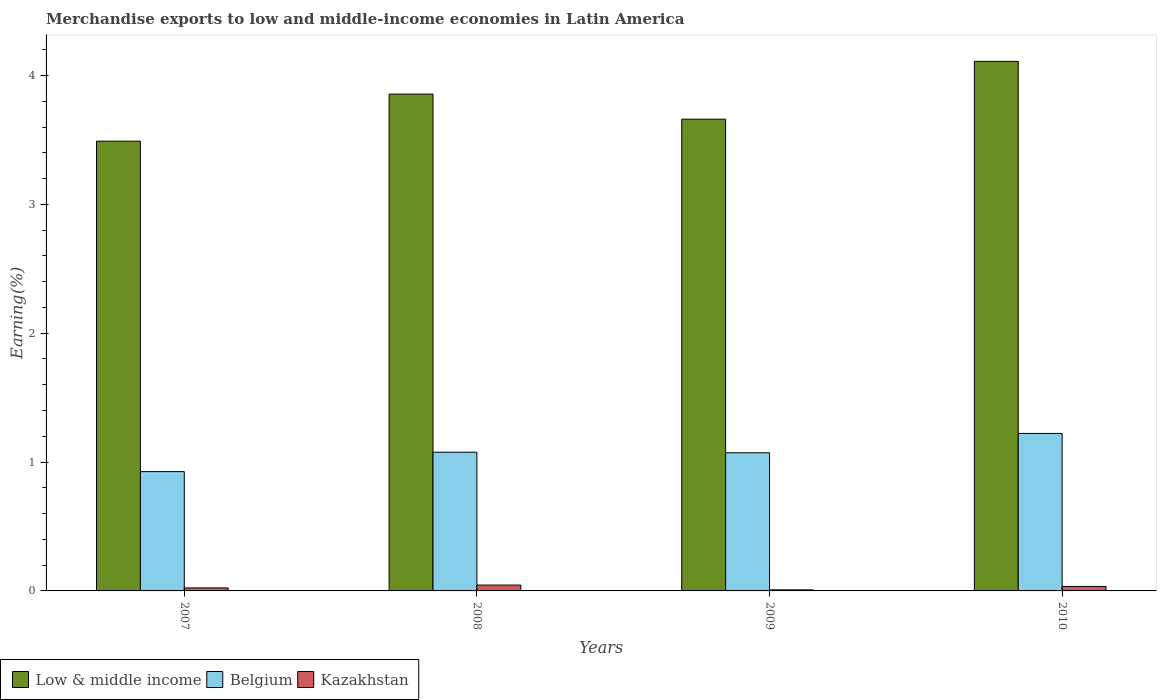How many different coloured bars are there?
Your answer should be compact. 3. Are the number of bars on each tick of the X-axis equal?
Your answer should be very brief. Yes. In how many cases, is the number of bars for a given year not equal to the number of legend labels?
Provide a succinct answer. 0. What is the percentage of amount earned from merchandise exports in Belgium in 2010?
Your response must be concise. 1.22. Across all years, what is the maximum percentage of amount earned from merchandise exports in Kazakhstan?
Ensure brevity in your answer.  0.05. Across all years, what is the minimum percentage of amount earned from merchandise exports in Belgium?
Your answer should be compact. 0.93. In which year was the percentage of amount earned from merchandise exports in Low & middle income maximum?
Your answer should be compact. 2010. In which year was the percentage of amount earned from merchandise exports in Belgium minimum?
Keep it short and to the point. 2007. What is the total percentage of amount earned from merchandise exports in Low & middle income in the graph?
Offer a very short reply. 15.12. What is the difference between the percentage of amount earned from merchandise exports in Low & middle income in 2008 and that in 2009?
Make the answer very short. 0.19. What is the difference between the percentage of amount earned from merchandise exports in Low & middle income in 2008 and the percentage of amount earned from merchandise exports in Kazakhstan in 2009?
Give a very brief answer. 3.85. What is the average percentage of amount earned from merchandise exports in Kazakhstan per year?
Your answer should be compact. 0.03. In the year 2009, what is the difference between the percentage of amount earned from merchandise exports in Kazakhstan and percentage of amount earned from merchandise exports in Belgium?
Give a very brief answer. -1.06. What is the ratio of the percentage of amount earned from merchandise exports in Belgium in 2009 to that in 2010?
Make the answer very short. 0.88. Is the difference between the percentage of amount earned from merchandise exports in Kazakhstan in 2007 and 2010 greater than the difference between the percentage of amount earned from merchandise exports in Belgium in 2007 and 2010?
Give a very brief answer. Yes. What is the difference between the highest and the second highest percentage of amount earned from merchandise exports in Low & middle income?
Offer a terse response. 0.25. What is the difference between the highest and the lowest percentage of amount earned from merchandise exports in Low & middle income?
Offer a terse response. 0.62. In how many years, is the percentage of amount earned from merchandise exports in Kazakhstan greater than the average percentage of amount earned from merchandise exports in Kazakhstan taken over all years?
Ensure brevity in your answer.  2. Is the sum of the percentage of amount earned from merchandise exports in Kazakhstan in 2008 and 2009 greater than the maximum percentage of amount earned from merchandise exports in Low & middle income across all years?
Your response must be concise. No. Are all the bars in the graph horizontal?
Offer a very short reply. No. How many years are there in the graph?
Offer a very short reply. 4. Does the graph contain grids?
Give a very brief answer. No. Where does the legend appear in the graph?
Your answer should be very brief. Bottom left. How many legend labels are there?
Your answer should be compact. 3. How are the legend labels stacked?
Offer a terse response. Horizontal. What is the title of the graph?
Give a very brief answer. Merchandise exports to low and middle-income economies in Latin America. What is the label or title of the X-axis?
Offer a very short reply. Years. What is the label or title of the Y-axis?
Offer a terse response. Earning(%). What is the Earning(%) of Low & middle income in 2007?
Provide a succinct answer. 3.49. What is the Earning(%) in Belgium in 2007?
Provide a short and direct response. 0.93. What is the Earning(%) of Kazakhstan in 2007?
Your answer should be compact. 0.02. What is the Earning(%) of Low & middle income in 2008?
Your answer should be compact. 3.86. What is the Earning(%) in Belgium in 2008?
Ensure brevity in your answer.  1.08. What is the Earning(%) in Kazakhstan in 2008?
Offer a very short reply. 0.05. What is the Earning(%) of Low & middle income in 2009?
Keep it short and to the point. 3.66. What is the Earning(%) in Belgium in 2009?
Ensure brevity in your answer.  1.07. What is the Earning(%) of Kazakhstan in 2009?
Provide a short and direct response. 0.01. What is the Earning(%) of Low & middle income in 2010?
Your answer should be very brief. 4.11. What is the Earning(%) in Belgium in 2010?
Ensure brevity in your answer.  1.22. What is the Earning(%) of Kazakhstan in 2010?
Provide a short and direct response. 0.03. Across all years, what is the maximum Earning(%) of Low & middle income?
Your answer should be very brief. 4.11. Across all years, what is the maximum Earning(%) in Belgium?
Provide a succinct answer. 1.22. Across all years, what is the maximum Earning(%) of Kazakhstan?
Provide a short and direct response. 0.05. Across all years, what is the minimum Earning(%) in Low & middle income?
Offer a terse response. 3.49. Across all years, what is the minimum Earning(%) in Belgium?
Your answer should be very brief. 0.93. Across all years, what is the minimum Earning(%) of Kazakhstan?
Your answer should be very brief. 0.01. What is the total Earning(%) in Low & middle income in the graph?
Your response must be concise. 15.12. What is the total Earning(%) in Belgium in the graph?
Keep it short and to the point. 4.3. What is the total Earning(%) of Kazakhstan in the graph?
Your answer should be compact. 0.11. What is the difference between the Earning(%) of Low & middle income in 2007 and that in 2008?
Your response must be concise. -0.37. What is the difference between the Earning(%) in Belgium in 2007 and that in 2008?
Your answer should be very brief. -0.15. What is the difference between the Earning(%) in Kazakhstan in 2007 and that in 2008?
Your response must be concise. -0.02. What is the difference between the Earning(%) in Low & middle income in 2007 and that in 2009?
Make the answer very short. -0.17. What is the difference between the Earning(%) in Belgium in 2007 and that in 2009?
Ensure brevity in your answer.  -0.15. What is the difference between the Earning(%) of Kazakhstan in 2007 and that in 2009?
Make the answer very short. 0.01. What is the difference between the Earning(%) of Low & middle income in 2007 and that in 2010?
Give a very brief answer. -0.62. What is the difference between the Earning(%) in Belgium in 2007 and that in 2010?
Keep it short and to the point. -0.3. What is the difference between the Earning(%) of Kazakhstan in 2007 and that in 2010?
Provide a succinct answer. -0.01. What is the difference between the Earning(%) in Low & middle income in 2008 and that in 2009?
Provide a short and direct response. 0.19. What is the difference between the Earning(%) in Belgium in 2008 and that in 2009?
Provide a succinct answer. 0. What is the difference between the Earning(%) of Kazakhstan in 2008 and that in 2009?
Provide a short and direct response. 0.04. What is the difference between the Earning(%) of Low & middle income in 2008 and that in 2010?
Offer a very short reply. -0.25. What is the difference between the Earning(%) of Belgium in 2008 and that in 2010?
Your answer should be very brief. -0.15. What is the difference between the Earning(%) of Kazakhstan in 2008 and that in 2010?
Provide a short and direct response. 0.01. What is the difference between the Earning(%) in Low & middle income in 2009 and that in 2010?
Offer a terse response. -0.45. What is the difference between the Earning(%) of Belgium in 2009 and that in 2010?
Offer a very short reply. -0.15. What is the difference between the Earning(%) of Kazakhstan in 2009 and that in 2010?
Your answer should be compact. -0.03. What is the difference between the Earning(%) in Low & middle income in 2007 and the Earning(%) in Belgium in 2008?
Offer a terse response. 2.41. What is the difference between the Earning(%) of Low & middle income in 2007 and the Earning(%) of Kazakhstan in 2008?
Ensure brevity in your answer.  3.44. What is the difference between the Earning(%) of Belgium in 2007 and the Earning(%) of Kazakhstan in 2008?
Keep it short and to the point. 0.88. What is the difference between the Earning(%) in Low & middle income in 2007 and the Earning(%) in Belgium in 2009?
Your answer should be very brief. 2.42. What is the difference between the Earning(%) in Low & middle income in 2007 and the Earning(%) in Kazakhstan in 2009?
Give a very brief answer. 3.48. What is the difference between the Earning(%) in Belgium in 2007 and the Earning(%) in Kazakhstan in 2009?
Ensure brevity in your answer.  0.92. What is the difference between the Earning(%) of Low & middle income in 2007 and the Earning(%) of Belgium in 2010?
Provide a short and direct response. 2.27. What is the difference between the Earning(%) of Low & middle income in 2007 and the Earning(%) of Kazakhstan in 2010?
Provide a succinct answer. 3.46. What is the difference between the Earning(%) of Belgium in 2007 and the Earning(%) of Kazakhstan in 2010?
Ensure brevity in your answer.  0.89. What is the difference between the Earning(%) of Low & middle income in 2008 and the Earning(%) of Belgium in 2009?
Give a very brief answer. 2.78. What is the difference between the Earning(%) in Low & middle income in 2008 and the Earning(%) in Kazakhstan in 2009?
Provide a short and direct response. 3.85. What is the difference between the Earning(%) of Belgium in 2008 and the Earning(%) of Kazakhstan in 2009?
Make the answer very short. 1.07. What is the difference between the Earning(%) of Low & middle income in 2008 and the Earning(%) of Belgium in 2010?
Provide a succinct answer. 2.63. What is the difference between the Earning(%) in Low & middle income in 2008 and the Earning(%) in Kazakhstan in 2010?
Provide a short and direct response. 3.82. What is the difference between the Earning(%) of Belgium in 2008 and the Earning(%) of Kazakhstan in 2010?
Keep it short and to the point. 1.04. What is the difference between the Earning(%) in Low & middle income in 2009 and the Earning(%) in Belgium in 2010?
Your response must be concise. 2.44. What is the difference between the Earning(%) of Low & middle income in 2009 and the Earning(%) of Kazakhstan in 2010?
Provide a short and direct response. 3.63. What is the difference between the Earning(%) of Belgium in 2009 and the Earning(%) of Kazakhstan in 2010?
Your answer should be very brief. 1.04. What is the average Earning(%) in Low & middle income per year?
Offer a very short reply. 3.78. What is the average Earning(%) of Belgium per year?
Your answer should be very brief. 1.07. What is the average Earning(%) of Kazakhstan per year?
Provide a succinct answer. 0.03. In the year 2007, what is the difference between the Earning(%) of Low & middle income and Earning(%) of Belgium?
Make the answer very short. 2.56. In the year 2007, what is the difference between the Earning(%) of Low & middle income and Earning(%) of Kazakhstan?
Offer a very short reply. 3.47. In the year 2007, what is the difference between the Earning(%) in Belgium and Earning(%) in Kazakhstan?
Your answer should be compact. 0.9. In the year 2008, what is the difference between the Earning(%) in Low & middle income and Earning(%) in Belgium?
Provide a short and direct response. 2.78. In the year 2008, what is the difference between the Earning(%) in Low & middle income and Earning(%) in Kazakhstan?
Make the answer very short. 3.81. In the year 2008, what is the difference between the Earning(%) of Belgium and Earning(%) of Kazakhstan?
Ensure brevity in your answer.  1.03. In the year 2009, what is the difference between the Earning(%) of Low & middle income and Earning(%) of Belgium?
Give a very brief answer. 2.59. In the year 2009, what is the difference between the Earning(%) in Low & middle income and Earning(%) in Kazakhstan?
Ensure brevity in your answer.  3.65. In the year 2009, what is the difference between the Earning(%) in Belgium and Earning(%) in Kazakhstan?
Keep it short and to the point. 1.06. In the year 2010, what is the difference between the Earning(%) in Low & middle income and Earning(%) in Belgium?
Your response must be concise. 2.89. In the year 2010, what is the difference between the Earning(%) of Low & middle income and Earning(%) of Kazakhstan?
Offer a very short reply. 4.07. In the year 2010, what is the difference between the Earning(%) of Belgium and Earning(%) of Kazakhstan?
Your response must be concise. 1.19. What is the ratio of the Earning(%) of Low & middle income in 2007 to that in 2008?
Ensure brevity in your answer.  0.91. What is the ratio of the Earning(%) in Belgium in 2007 to that in 2008?
Provide a short and direct response. 0.86. What is the ratio of the Earning(%) of Kazakhstan in 2007 to that in 2008?
Provide a succinct answer. 0.51. What is the ratio of the Earning(%) in Low & middle income in 2007 to that in 2009?
Provide a succinct answer. 0.95. What is the ratio of the Earning(%) in Belgium in 2007 to that in 2009?
Your answer should be compact. 0.86. What is the ratio of the Earning(%) in Kazakhstan in 2007 to that in 2009?
Your answer should be very brief. 2.84. What is the ratio of the Earning(%) of Low & middle income in 2007 to that in 2010?
Your response must be concise. 0.85. What is the ratio of the Earning(%) in Belgium in 2007 to that in 2010?
Your answer should be compact. 0.76. What is the ratio of the Earning(%) in Kazakhstan in 2007 to that in 2010?
Your response must be concise. 0.67. What is the ratio of the Earning(%) in Low & middle income in 2008 to that in 2009?
Your answer should be very brief. 1.05. What is the ratio of the Earning(%) in Belgium in 2008 to that in 2009?
Make the answer very short. 1. What is the ratio of the Earning(%) in Kazakhstan in 2008 to that in 2009?
Make the answer very short. 5.56. What is the ratio of the Earning(%) in Low & middle income in 2008 to that in 2010?
Provide a short and direct response. 0.94. What is the ratio of the Earning(%) in Belgium in 2008 to that in 2010?
Make the answer very short. 0.88. What is the ratio of the Earning(%) of Kazakhstan in 2008 to that in 2010?
Offer a very short reply. 1.31. What is the ratio of the Earning(%) in Low & middle income in 2009 to that in 2010?
Keep it short and to the point. 0.89. What is the ratio of the Earning(%) in Belgium in 2009 to that in 2010?
Keep it short and to the point. 0.88. What is the ratio of the Earning(%) of Kazakhstan in 2009 to that in 2010?
Provide a short and direct response. 0.24. What is the difference between the highest and the second highest Earning(%) in Low & middle income?
Your answer should be very brief. 0.25. What is the difference between the highest and the second highest Earning(%) in Belgium?
Ensure brevity in your answer.  0.15. What is the difference between the highest and the second highest Earning(%) of Kazakhstan?
Your answer should be very brief. 0.01. What is the difference between the highest and the lowest Earning(%) of Low & middle income?
Make the answer very short. 0.62. What is the difference between the highest and the lowest Earning(%) of Belgium?
Ensure brevity in your answer.  0.3. What is the difference between the highest and the lowest Earning(%) in Kazakhstan?
Your answer should be compact. 0.04. 